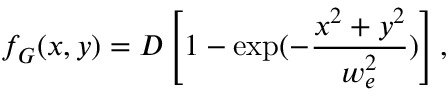<formula> <loc_0><loc_0><loc_500><loc_500>f _ { G } ( x , y ) = D \left [ 1 - \exp ( - \frac { x ^ { 2 } + y ^ { 2 } } { w _ { e } ^ { 2 } } ) \right ] ,</formula> 